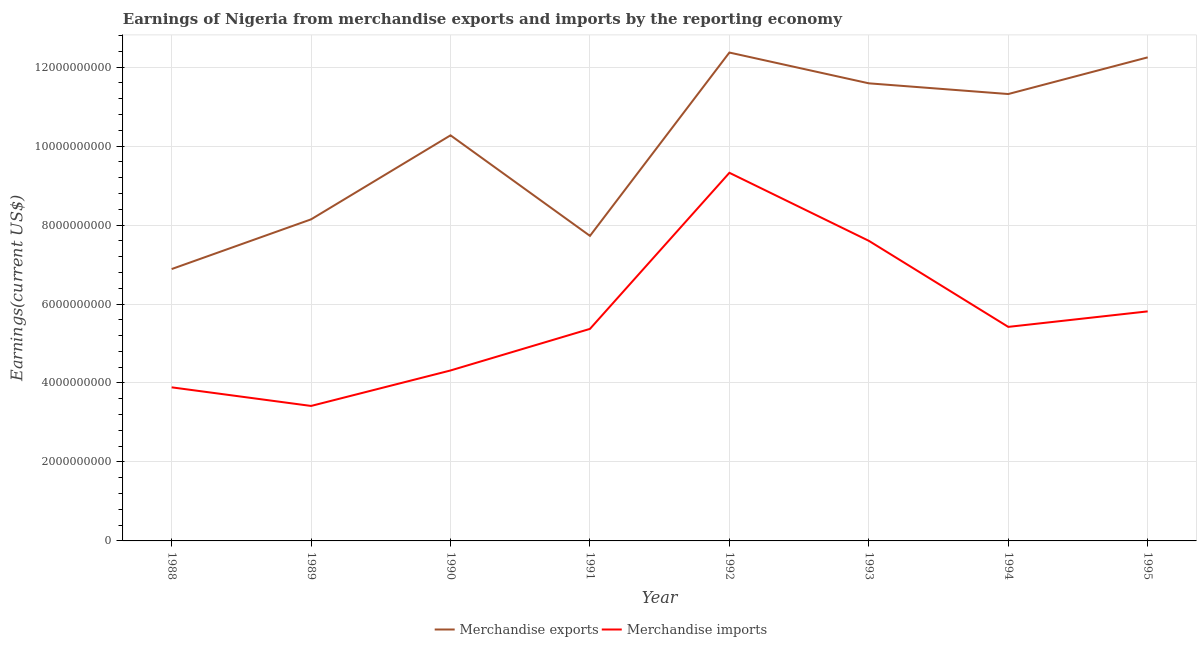How many different coloured lines are there?
Your answer should be compact. 2. What is the earnings from merchandise imports in 1988?
Your response must be concise. 3.89e+09. Across all years, what is the maximum earnings from merchandise imports?
Keep it short and to the point. 9.32e+09. Across all years, what is the minimum earnings from merchandise exports?
Offer a very short reply. 6.89e+09. In which year was the earnings from merchandise imports maximum?
Keep it short and to the point. 1992. In which year was the earnings from merchandise imports minimum?
Offer a very short reply. 1989. What is the total earnings from merchandise exports in the graph?
Keep it short and to the point. 8.06e+1. What is the difference between the earnings from merchandise imports in 1989 and that in 1991?
Make the answer very short. -1.95e+09. What is the difference between the earnings from merchandise imports in 1988 and the earnings from merchandise exports in 1990?
Provide a succinct answer. -6.38e+09. What is the average earnings from merchandise imports per year?
Offer a very short reply. 5.64e+09. In the year 1993, what is the difference between the earnings from merchandise exports and earnings from merchandise imports?
Your answer should be compact. 3.99e+09. In how many years, is the earnings from merchandise imports greater than 8000000000 US$?
Provide a succinct answer. 1. What is the ratio of the earnings from merchandise exports in 1990 to that in 1992?
Make the answer very short. 0.83. Is the earnings from merchandise imports in 1988 less than that in 1989?
Your response must be concise. No. Is the difference between the earnings from merchandise exports in 1989 and 1994 greater than the difference between the earnings from merchandise imports in 1989 and 1994?
Your answer should be compact. No. What is the difference between the highest and the second highest earnings from merchandise exports?
Your answer should be very brief. 1.22e+08. What is the difference between the highest and the lowest earnings from merchandise imports?
Provide a short and direct response. 5.91e+09. Is the sum of the earnings from merchandise imports in 1989 and 1993 greater than the maximum earnings from merchandise exports across all years?
Offer a terse response. No. How many lines are there?
Ensure brevity in your answer.  2. Are the values on the major ticks of Y-axis written in scientific E-notation?
Your answer should be very brief. No. Does the graph contain any zero values?
Make the answer very short. No. Does the graph contain grids?
Provide a short and direct response. Yes. Where does the legend appear in the graph?
Ensure brevity in your answer.  Bottom center. How many legend labels are there?
Your answer should be very brief. 2. What is the title of the graph?
Provide a succinct answer. Earnings of Nigeria from merchandise exports and imports by the reporting economy. What is the label or title of the X-axis?
Provide a short and direct response. Year. What is the label or title of the Y-axis?
Offer a terse response. Earnings(current US$). What is the Earnings(current US$) of Merchandise exports in 1988?
Your answer should be compact. 6.89e+09. What is the Earnings(current US$) in Merchandise imports in 1988?
Offer a very short reply. 3.89e+09. What is the Earnings(current US$) of Merchandise exports in 1989?
Keep it short and to the point. 8.14e+09. What is the Earnings(current US$) in Merchandise imports in 1989?
Offer a terse response. 3.42e+09. What is the Earnings(current US$) of Merchandise exports in 1990?
Keep it short and to the point. 1.03e+1. What is the Earnings(current US$) in Merchandise imports in 1990?
Your answer should be very brief. 4.32e+09. What is the Earnings(current US$) of Merchandise exports in 1991?
Offer a very short reply. 7.73e+09. What is the Earnings(current US$) of Merchandise imports in 1991?
Your response must be concise. 5.37e+09. What is the Earnings(current US$) of Merchandise exports in 1992?
Your answer should be compact. 1.24e+1. What is the Earnings(current US$) of Merchandise imports in 1992?
Give a very brief answer. 9.32e+09. What is the Earnings(current US$) in Merchandise exports in 1993?
Make the answer very short. 1.16e+1. What is the Earnings(current US$) in Merchandise imports in 1993?
Offer a terse response. 7.60e+09. What is the Earnings(current US$) of Merchandise exports in 1994?
Make the answer very short. 1.13e+1. What is the Earnings(current US$) of Merchandise imports in 1994?
Make the answer very short. 5.42e+09. What is the Earnings(current US$) of Merchandise exports in 1995?
Keep it short and to the point. 1.22e+1. What is the Earnings(current US$) in Merchandise imports in 1995?
Make the answer very short. 5.81e+09. Across all years, what is the maximum Earnings(current US$) of Merchandise exports?
Your answer should be very brief. 1.24e+1. Across all years, what is the maximum Earnings(current US$) of Merchandise imports?
Offer a very short reply. 9.32e+09. Across all years, what is the minimum Earnings(current US$) in Merchandise exports?
Offer a terse response. 6.89e+09. Across all years, what is the minimum Earnings(current US$) in Merchandise imports?
Provide a succinct answer. 3.42e+09. What is the total Earnings(current US$) of Merchandise exports in the graph?
Ensure brevity in your answer.  8.06e+1. What is the total Earnings(current US$) in Merchandise imports in the graph?
Offer a very short reply. 4.52e+1. What is the difference between the Earnings(current US$) of Merchandise exports in 1988 and that in 1989?
Offer a terse response. -1.26e+09. What is the difference between the Earnings(current US$) in Merchandise imports in 1988 and that in 1989?
Offer a terse response. 4.71e+08. What is the difference between the Earnings(current US$) in Merchandise exports in 1988 and that in 1990?
Make the answer very short. -3.39e+09. What is the difference between the Earnings(current US$) of Merchandise imports in 1988 and that in 1990?
Offer a terse response. -4.27e+08. What is the difference between the Earnings(current US$) of Merchandise exports in 1988 and that in 1991?
Keep it short and to the point. -8.41e+08. What is the difference between the Earnings(current US$) of Merchandise imports in 1988 and that in 1991?
Your answer should be compact. -1.48e+09. What is the difference between the Earnings(current US$) of Merchandise exports in 1988 and that in 1992?
Give a very brief answer. -5.48e+09. What is the difference between the Earnings(current US$) in Merchandise imports in 1988 and that in 1992?
Offer a terse response. -5.43e+09. What is the difference between the Earnings(current US$) in Merchandise exports in 1988 and that in 1993?
Your answer should be very brief. -4.70e+09. What is the difference between the Earnings(current US$) in Merchandise imports in 1988 and that in 1993?
Your answer should be compact. -3.71e+09. What is the difference between the Earnings(current US$) in Merchandise exports in 1988 and that in 1994?
Offer a very short reply. -4.43e+09. What is the difference between the Earnings(current US$) in Merchandise imports in 1988 and that in 1994?
Your answer should be very brief. -1.53e+09. What is the difference between the Earnings(current US$) in Merchandise exports in 1988 and that in 1995?
Your response must be concise. -5.36e+09. What is the difference between the Earnings(current US$) in Merchandise imports in 1988 and that in 1995?
Keep it short and to the point. -1.92e+09. What is the difference between the Earnings(current US$) of Merchandise exports in 1989 and that in 1990?
Your answer should be compact. -2.13e+09. What is the difference between the Earnings(current US$) in Merchandise imports in 1989 and that in 1990?
Your answer should be very brief. -8.99e+08. What is the difference between the Earnings(current US$) in Merchandise exports in 1989 and that in 1991?
Your response must be concise. 4.19e+08. What is the difference between the Earnings(current US$) in Merchandise imports in 1989 and that in 1991?
Your answer should be very brief. -1.95e+09. What is the difference between the Earnings(current US$) in Merchandise exports in 1989 and that in 1992?
Provide a short and direct response. -4.22e+09. What is the difference between the Earnings(current US$) in Merchandise imports in 1989 and that in 1992?
Your response must be concise. -5.91e+09. What is the difference between the Earnings(current US$) of Merchandise exports in 1989 and that in 1993?
Your response must be concise. -3.45e+09. What is the difference between the Earnings(current US$) in Merchandise imports in 1989 and that in 1993?
Your answer should be compact. -4.18e+09. What is the difference between the Earnings(current US$) in Merchandise exports in 1989 and that in 1994?
Keep it short and to the point. -3.17e+09. What is the difference between the Earnings(current US$) in Merchandise imports in 1989 and that in 1994?
Keep it short and to the point. -2.00e+09. What is the difference between the Earnings(current US$) of Merchandise exports in 1989 and that in 1995?
Make the answer very short. -4.10e+09. What is the difference between the Earnings(current US$) of Merchandise imports in 1989 and that in 1995?
Your response must be concise. -2.40e+09. What is the difference between the Earnings(current US$) of Merchandise exports in 1990 and that in 1991?
Provide a succinct answer. 2.55e+09. What is the difference between the Earnings(current US$) in Merchandise imports in 1990 and that in 1991?
Provide a succinct answer. -1.05e+09. What is the difference between the Earnings(current US$) of Merchandise exports in 1990 and that in 1992?
Provide a succinct answer. -2.10e+09. What is the difference between the Earnings(current US$) of Merchandise imports in 1990 and that in 1992?
Make the answer very short. -5.01e+09. What is the difference between the Earnings(current US$) of Merchandise exports in 1990 and that in 1993?
Ensure brevity in your answer.  -1.32e+09. What is the difference between the Earnings(current US$) of Merchandise imports in 1990 and that in 1993?
Provide a short and direct response. -3.28e+09. What is the difference between the Earnings(current US$) in Merchandise exports in 1990 and that in 1994?
Provide a succinct answer. -1.05e+09. What is the difference between the Earnings(current US$) of Merchandise imports in 1990 and that in 1994?
Offer a terse response. -1.10e+09. What is the difference between the Earnings(current US$) in Merchandise exports in 1990 and that in 1995?
Your answer should be compact. -1.97e+09. What is the difference between the Earnings(current US$) in Merchandise imports in 1990 and that in 1995?
Offer a very short reply. -1.50e+09. What is the difference between the Earnings(current US$) in Merchandise exports in 1991 and that in 1992?
Offer a terse response. -4.64e+09. What is the difference between the Earnings(current US$) in Merchandise imports in 1991 and that in 1992?
Your answer should be compact. -3.95e+09. What is the difference between the Earnings(current US$) of Merchandise exports in 1991 and that in 1993?
Give a very brief answer. -3.86e+09. What is the difference between the Earnings(current US$) of Merchandise imports in 1991 and that in 1993?
Your response must be concise. -2.23e+09. What is the difference between the Earnings(current US$) in Merchandise exports in 1991 and that in 1994?
Offer a very short reply. -3.59e+09. What is the difference between the Earnings(current US$) in Merchandise imports in 1991 and that in 1994?
Provide a short and direct response. -5.08e+07. What is the difference between the Earnings(current US$) in Merchandise exports in 1991 and that in 1995?
Provide a succinct answer. -4.52e+09. What is the difference between the Earnings(current US$) in Merchandise imports in 1991 and that in 1995?
Provide a succinct answer. -4.44e+08. What is the difference between the Earnings(current US$) of Merchandise exports in 1992 and that in 1993?
Make the answer very short. 7.80e+08. What is the difference between the Earnings(current US$) in Merchandise imports in 1992 and that in 1993?
Give a very brief answer. 1.72e+09. What is the difference between the Earnings(current US$) in Merchandise exports in 1992 and that in 1994?
Your response must be concise. 1.05e+09. What is the difference between the Earnings(current US$) of Merchandise imports in 1992 and that in 1994?
Keep it short and to the point. 3.90e+09. What is the difference between the Earnings(current US$) of Merchandise exports in 1992 and that in 1995?
Your response must be concise. 1.22e+08. What is the difference between the Earnings(current US$) of Merchandise imports in 1992 and that in 1995?
Your answer should be very brief. 3.51e+09. What is the difference between the Earnings(current US$) in Merchandise exports in 1993 and that in 1994?
Offer a terse response. 2.71e+08. What is the difference between the Earnings(current US$) of Merchandise imports in 1993 and that in 1994?
Your response must be concise. 2.18e+09. What is the difference between the Earnings(current US$) of Merchandise exports in 1993 and that in 1995?
Your answer should be very brief. -6.58e+08. What is the difference between the Earnings(current US$) of Merchandise imports in 1993 and that in 1995?
Offer a very short reply. 1.79e+09. What is the difference between the Earnings(current US$) in Merchandise exports in 1994 and that in 1995?
Offer a terse response. -9.29e+08. What is the difference between the Earnings(current US$) in Merchandise imports in 1994 and that in 1995?
Keep it short and to the point. -3.93e+08. What is the difference between the Earnings(current US$) in Merchandise exports in 1988 and the Earnings(current US$) in Merchandise imports in 1989?
Your response must be concise. 3.47e+09. What is the difference between the Earnings(current US$) in Merchandise exports in 1988 and the Earnings(current US$) in Merchandise imports in 1990?
Provide a short and direct response. 2.57e+09. What is the difference between the Earnings(current US$) in Merchandise exports in 1988 and the Earnings(current US$) in Merchandise imports in 1991?
Offer a very short reply. 1.52e+09. What is the difference between the Earnings(current US$) in Merchandise exports in 1988 and the Earnings(current US$) in Merchandise imports in 1992?
Your answer should be very brief. -2.44e+09. What is the difference between the Earnings(current US$) of Merchandise exports in 1988 and the Earnings(current US$) of Merchandise imports in 1993?
Keep it short and to the point. -7.15e+08. What is the difference between the Earnings(current US$) of Merchandise exports in 1988 and the Earnings(current US$) of Merchandise imports in 1994?
Keep it short and to the point. 1.46e+09. What is the difference between the Earnings(current US$) in Merchandise exports in 1988 and the Earnings(current US$) in Merchandise imports in 1995?
Offer a very short reply. 1.07e+09. What is the difference between the Earnings(current US$) of Merchandise exports in 1989 and the Earnings(current US$) of Merchandise imports in 1990?
Keep it short and to the point. 3.83e+09. What is the difference between the Earnings(current US$) in Merchandise exports in 1989 and the Earnings(current US$) in Merchandise imports in 1991?
Offer a terse response. 2.77e+09. What is the difference between the Earnings(current US$) of Merchandise exports in 1989 and the Earnings(current US$) of Merchandise imports in 1992?
Your response must be concise. -1.18e+09. What is the difference between the Earnings(current US$) in Merchandise exports in 1989 and the Earnings(current US$) in Merchandise imports in 1993?
Keep it short and to the point. 5.44e+08. What is the difference between the Earnings(current US$) in Merchandise exports in 1989 and the Earnings(current US$) in Merchandise imports in 1994?
Your answer should be compact. 2.72e+09. What is the difference between the Earnings(current US$) in Merchandise exports in 1989 and the Earnings(current US$) in Merchandise imports in 1995?
Provide a succinct answer. 2.33e+09. What is the difference between the Earnings(current US$) in Merchandise exports in 1990 and the Earnings(current US$) in Merchandise imports in 1991?
Provide a short and direct response. 4.90e+09. What is the difference between the Earnings(current US$) of Merchandise exports in 1990 and the Earnings(current US$) of Merchandise imports in 1992?
Your answer should be very brief. 9.49e+08. What is the difference between the Earnings(current US$) of Merchandise exports in 1990 and the Earnings(current US$) of Merchandise imports in 1993?
Ensure brevity in your answer.  2.67e+09. What is the difference between the Earnings(current US$) in Merchandise exports in 1990 and the Earnings(current US$) in Merchandise imports in 1994?
Offer a very short reply. 4.85e+09. What is the difference between the Earnings(current US$) of Merchandise exports in 1990 and the Earnings(current US$) of Merchandise imports in 1995?
Offer a terse response. 4.46e+09. What is the difference between the Earnings(current US$) of Merchandise exports in 1991 and the Earnings(current US$) of Merchandise imports in 1992?
Give a very brief answer. -1.60e+09. What is the difference between the Earnings(current US$) of Merchandise exports in 1991 and the Earnings(current US$) of Merchandise imports in 1993?
Your answer should be very brief. 1.26e+08. What is the difference between the Earnings(current US$) of Merchandise exports in 1991 and the Earnings(current US$) of Merchandise imports in 1994?
Ensure brevity in your answer.  2.31e+09. What is the difference between the Earnings(current US$) in Merchandise exports in 1991 and the Earnings(current US$) in Merchandise imports in 1995?
Offer a terse response. 1.91e+09. What is the difference between the Earnings(current US$) of Merchandise exports in 1992 and the Earnings(current US$) of Merchandise imports in 1993?
Offer a very short reply. 4.77e+09. What is the difference between the Earnings(current US$) of Merchandise exports in 1992 and the Earnings(current US$) of Merchandise imports in 1994?
Your answer should be compact. 6.95e+09. What is the difference between the Earnings(current US$) in Merchandise exports in 1992 and the Earnings(current US$) in Merchandise imports in 1995?
Offer a very short reply. 6.56e+09. What is the difference between the Earnings(current US$) in Merchandise exports in 1993 and the Earnings(current US$) in Merchandise imports in 1994?
Your answer should be very brief. 6.17e+09. What is the difference between the Earnings(current US$) in Merchandise exports in 1993 and the Earnings(current US$) in Merchandise imports in 1995?
Your answer should be very brief. 5.78e+09. What is the difference between the Earnings(current US$) of Merchandise exports in 1994 and the Earnings(current US$) of Merchandise imports in 1995?
Make the answer very short. 5.50e+09. What is the average Earnings(current US$) in Merchandise exports per year?
Ensure brevity in your answer.  1.01e+1. What is the average Earnings(current US$) of Merchandise imports per year?
Ensure brevity in your answer.  5.64e+09. In the year 1988, what is the difference between the Earnings(current US$) of Merchandise exports and Earnings(current US$) of Merchandise imports?
Your answer should be compact. 3.00e+09. In the year 1989, what is the difference between the Earnings(current US$) in Merchandise exports and Earnings(current US$) in Merchandise imports?
Provide a succinct answer. 4.73e+09. In the year 1990, what is the difference between the Earnings(current US$) in Merchandise exports and Earnings(current US$) in Merchandise imports?
Your answer should be compact. 5.96e+09. In the year 1991, what is the difference between the Earnings(current US$) in Merchandise exports and Earnings(current US$) in Merchandise imports?
Provide a succinct answer. 2.36e+09. In the year 1992, what is the difference between the Earnings(current US$) of Merchandise exports and Earnings(current US$) of Merchandise imports?
Your answer should be very brief. 3.05e+09. In the year 1993, what is the difference between the Earnings(current US$) of Merchandise exports and Earnings(current US$) of Merchandise imports?
Keep it short and to the point. 3.99e+09. In the year 1994, what is the difference between the Earnings(current US$) in Merchandise exports and Earnings(current US$) in Merchandise imports?
Your answer should be compact. 5.90e+09. In the year 1995, what is the difference between the Earnings(current US$) of Merchandise exports and Earnings(current US$) of Merchandise imports?
Your answer should be very brief. 6.43e+09. What is the ratio of the Earnings(current US$) in Merchandise exports in 1988 to that in 1989?
Keep it short and to the point. 0.85. What is the ratio of the Earnings(current US$) in Merchandise imports in 1988 to that in 1989?
Offer a terse response. 1.14. What is the ratio of the Earnings(current US$) in Merchandise exports in 1988 to that in 1990?
Offer a terse response. 0.67. What is the ratio of the Earnings(current US$) of Merchandise imports in 1988 to that in 1990?
Offer a terse response. 0.9. What is the ratio of the Earnings(current US$) in Merchandise exports in 1988 to that in 1991?
Ensure brevity in your answer.  0.89. What is the ratio of the Earnings(current US$) in Merchandise imports in 1988 to that in 1991?
Keep it short and to the point. 0.72. What is the ratio of the Earnings(current US$) of Merchandise exports in 1988 to that in 1992?
Your response must be concise. 0.56. What is the ratio of the Earnings(current US$) of Merchandise imports in 1988 to that in 1992?
Your answer should be very brief. 0.42. What is the ratio of the Earnings(current US$) of Merchandise exports in 1988 to that in 1993?
Your answer should be compact. 0.59. What is the ratio of the Earnings(current US$) of Merchandise imports in 1988 to that in 1993?
Your response must be concise. 0.51. What is the ratio of the Earnings(current US$) in Merchandise exports in 1988 to that in 1994?
Make the answer very short. 0.61. What is the ratio of the Earnings(current US$) of Merchandise imports in 1988 to that in 1994?
Your answer should be very brief. 0.72. What is the ratio of the Earnings(current US$) in Merchandise exports in 1988 to that in 1995?
Your answer should be compact. 0.56. What is the ratio of the Earnings(current US$) in Merchandise imports in 1988 to that in 1995?
Ensure brevity in your answer.  0.67. What is the ratio of the Earnings(current US$) of Merchandise exports in 1989 to that in 1990?
Provide a short and direct response. 0.79. What is the ratio of the Earnings(current US$) in Merchandise imports in 1989 to that in 1990?
Give a very brief answer. 0.79. What is the ratio of the Earnings(current US$) in Merchandise exports in 1989 to that in 1991?
Give a very brief answer. 1.05. What is the ratio of the Earnings(current US$) of Merchandise imports in 1989 to that in 1991?
Provide a short and direct response. 0.64. What is the ratio of the Earnings(current US$) in Merchandise exports in 1989 to that in 1992?
Your answer should be compact. 0.66. What is the ratio of the Earnings(current US$) of Merchandise imports in 1989 to that in 1992?
Keep it short and to the point. 0.37. What is the ratio of the Earnings(current US$) in Merchandise exports in 1989 to that in 1993?
Keep it short and to the point. 0.7. What is the ratio of the Earnings(current US$) of Merchandise imports in 1989 to that in 1993?
Your response must be concise. 0.45. What is the ratio of the Earnings(current US$) of Merchandise exports in 1989 to that in 1994?
Make the answer very short. 0.72. What is the ratio of the Earnings(current US$) in Merchandise imports in 1989 to that in 1994?
Your answer should be compact. 0.63. What is the ratio of the Earnings(current US$) of Merchandise exports in 1989 to that in 1995?
Your answer should be very brief. 0.67. What is the ratio of the Earnings(current US$) of Merchandise imports in 1989 to that in 1995?
Provide a succinct answer. 0.59. What is the ratio of the Earnings(current US$) of Merchandise exports in 1990 to that in 1991?
Make the answer very short. 1.33. What is the ratio of the Earnings(current US$) of Merchandise imports in 1990 to that in 1991?
Your answer should be compact. 0.8. What is the ratio of the Earnings(current US$) of Merchandise exports in 1990 to that in 1992?
Ensure brevity in your answer.  0.83. What is the ratio of the Earnings(current US$) of Merchandise imports in 1990 to that in 1992?
Your answer should be compact. 0.46. What is the ratio of the Earnings(current US$) in Merchandise exports in 1990 to that in 1993?
Your answer should be compact. 0.89. What is the ratio of the Earnings(current US$) of Merchandise imports in 1990 to that in 1993?
Your answer should be very brief. 0.57. What is the ratio of the Earnings(current US$) in Merchandise exports in 1990 to that in 1994?
Your answer should be compact. 0.91. What is the ratio of the Earnings(current US$) of Merchandise imports in 1990 to that in 1994?
Ensure brevity in your answer.  0.8. What is the ratio of the Earnings(current US$) of Merchandise exports in 1990 to that in 1995?
Provide a short and direct response. 0.84. What is the ratio of the Earnings(current US$) in Merchandise imports in 1990 to that in 1995?
Provide a short and direct response. 0.74. What is the ratio of the Earnings(current US$) of Merchandise exports in 1991 to that in 1992?
Offer a very short reply. 0.62. What is the ratio of the Earnings(current US$) of Merchandise imports in 1991 to that in 1992?
Provide a short and direct response. 0.58. What is the ratio of the Earnings(current US$) of Merchandise exports in 1991 to that in 1993?
Your answer should be very brief. 0.67. What is the ratio of the Earnings(current US$) in Merchandise imports in 1991 to that in 1993?
Keep it short and to the point. 0.71. What is the ratio of the Earnings(current US$) in Merchandise exports in 1991 to that in 1994?
Ensure brevity in your answer.  0.68. What is the ratio of the Earnings(current US$) of Merchandise imports in 1991 to that in 1994?
Ensure brevity in your answer.  0.99. What is the ratio of the Earnings(current US$) of Merchandise exports in 1991 to that in 1995?
Your answer should be very brief. 0.63. What is the ratio of the Earnings(current US$) in Merchandise imports in 1991 to that in 1995?
Offer a terse response. 0.92. What is the ratio of the Earnings(current US$) in Merchandise exports in 1992 to that in 1993?
Provide a short and direct response. 1.07. What is the ratio of the Earnings(current US$) of Merchandise imports in 1992 to that in 1993?
Offer a terse response. 1.23. What is the ratio of the Earnings(current US$) in Merchandise exports in 1992 to that in 1994?
Your answer should be compact. 1.09. What is the ratio of the Earnings(current US$) of Merchandise imports in 1992 to that in 1994?
Offer a very short reply. 1.72. What is the ratio of the Earnings(current US$) in Merchandise exports in 1992 to that in 1995?
Offer a terse response. 1.01. What is the ratio of the Earnings(current US$) in Merchandise imports in 1992 to that in 1995?
Your response must be concise. 1.6. What is the ratio of the Earnings(current US$) in Merchandise imports in 1993 to that in 1994?
Your answer should be very brief. 1.4. What is the ratio of the Earnings(current US$) in Merchandise exports in 1993 to that in 1995?
Keep it short and to the point. 0.95. What is the ratio of the Earnings(current US$) in Merchandise imports in 1993 to that in 1995?
Your response must be concise. 1.31. What is the ratio of the Earnings(current US$) in Merchandise exports in 1994 to that in 1995?
Offer a very short reply. 0.92. What is the ratio of the Earnings(current US$) of Merchandise imports in 1994 to that in 1995?
Give a very brief answer. 0.93. What is the difference between the highest and the second highest Earnings(current US$) of Merchandise exports?
Offer a terse response. 1.22e+08. What is the difference between the highest and the second highest Earnings(current US$) in Merchandise imports?
Ensure brevity in your answer.  1.72e+09. What is the difference between the highest and the lowest Earnings(current US$) in Merchandise exports?
Ensure brevity in your answer.  5.48e+09. What is the difference between the highest and the lowest Earnings(current US$) in Merchandise imports?
Ensure brevity in your answer.  5.91e+09. 